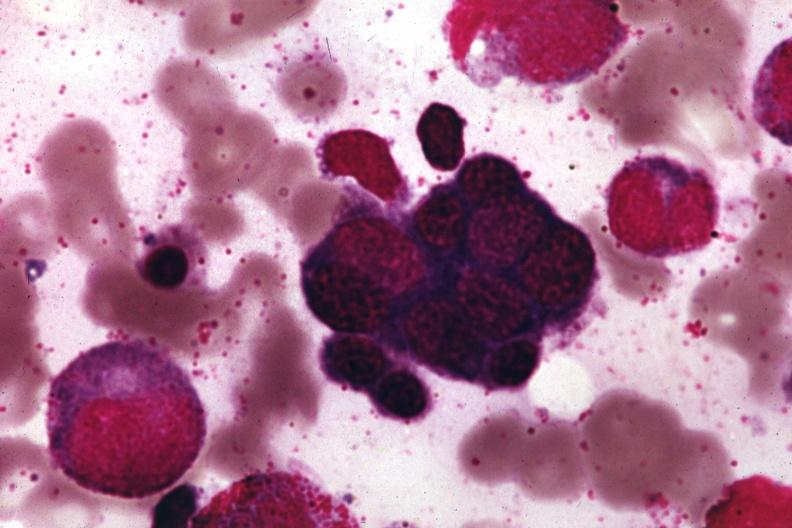s case of dic not bad photo present?
Answer the question using a single word or phrase. No 